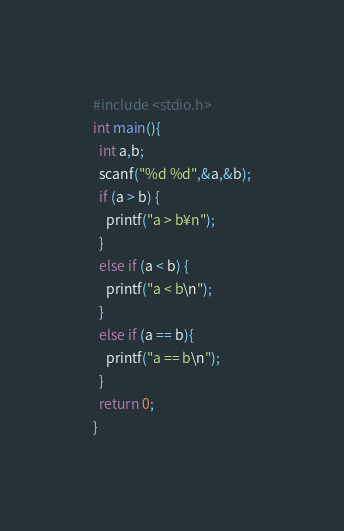Convert code to text. <code><loc_0><loc_0><loc_500><loc_500><_C_>#include <stdio.h>
int main(){
  int a,b;
  scanf("%d %d",&a,&b);
  if (a > b) {
    printf("a > b¥n");
  }
  else if (a < b) {
    printf("a < b\n"); 
  }
  else if (a == b){
    printf("a == b\n");
  }
  return 0;
}
</code> 